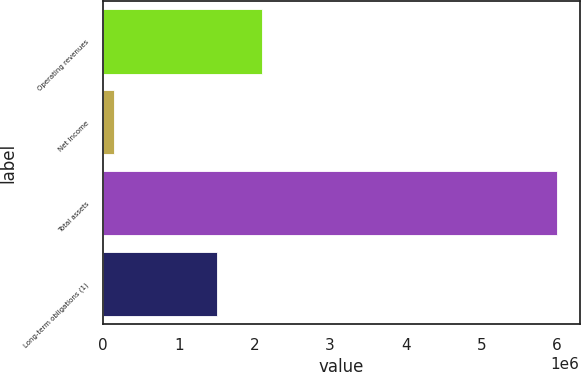<chart> <loc_0><loc_0><loc_500><loc_500><bar_chart><fcel>Operating revenues<fcel>Net Income<fcel>Total assets<fcel>Long-term obligations (1)<nl><fcel>2.09423e+06<fcel>139111<fcel>5.99981e+06<fcel>1.50816e+06<nl></chart> 